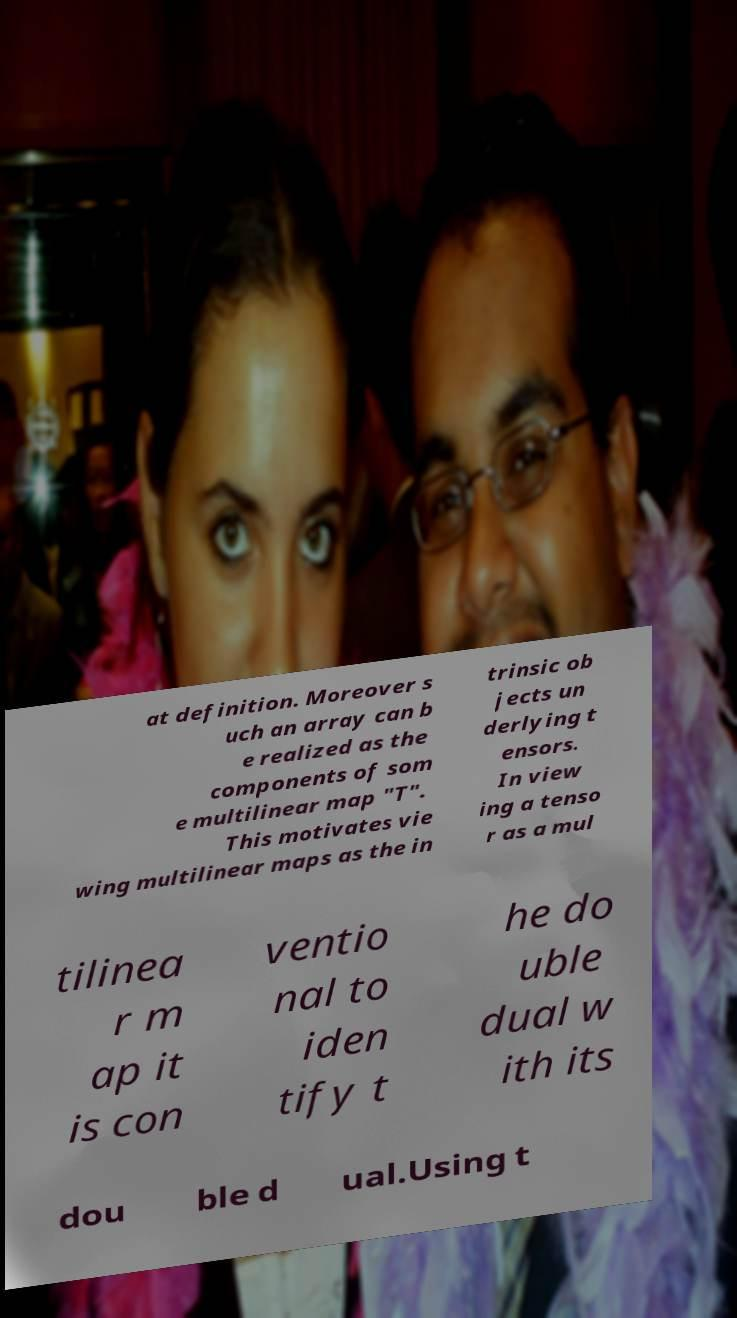Can you accurately transcribe the text from the provided image for me? at definition. Moreover s uch an array can b e realized as the components of som e multilinear map "T". This motivates vie wing multilinear maps as the in trinsic ob jects un derlying t ensors. In view ing a tenso r as a mul tilinea r m ap it is con ventio nal to iden tify t he do uble dual w ith its dou ble d ual.Using t 